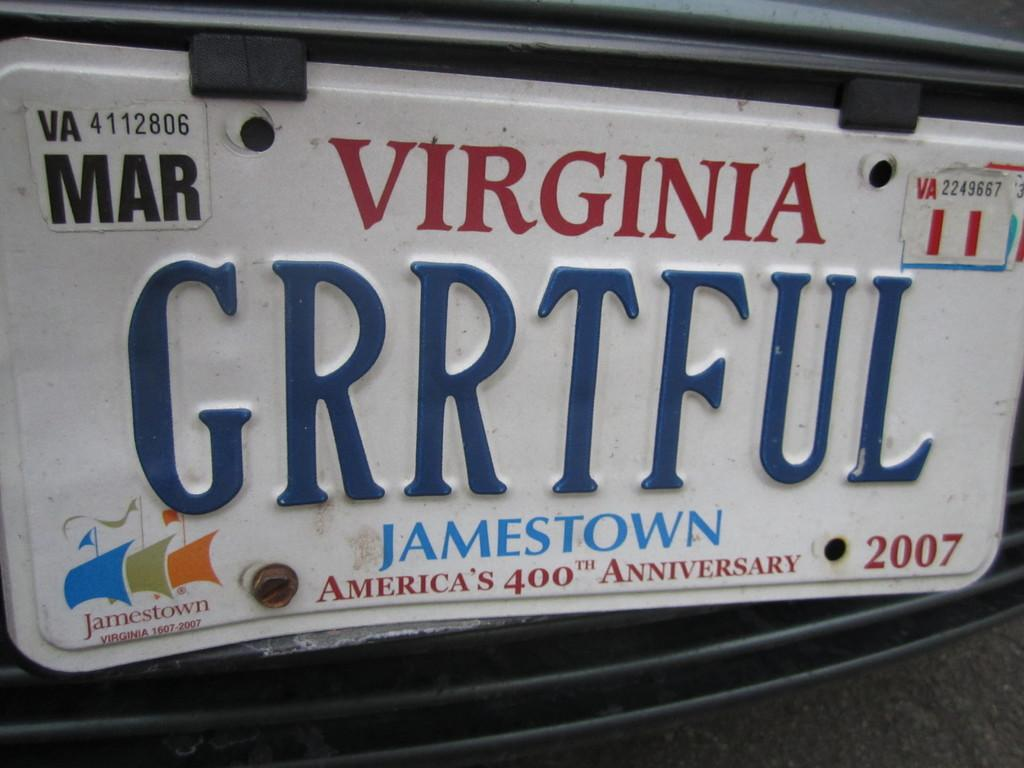<image>
Describe the image concisely. The person who drives this vehicle is both GRRTFUL and from Virginia.. 